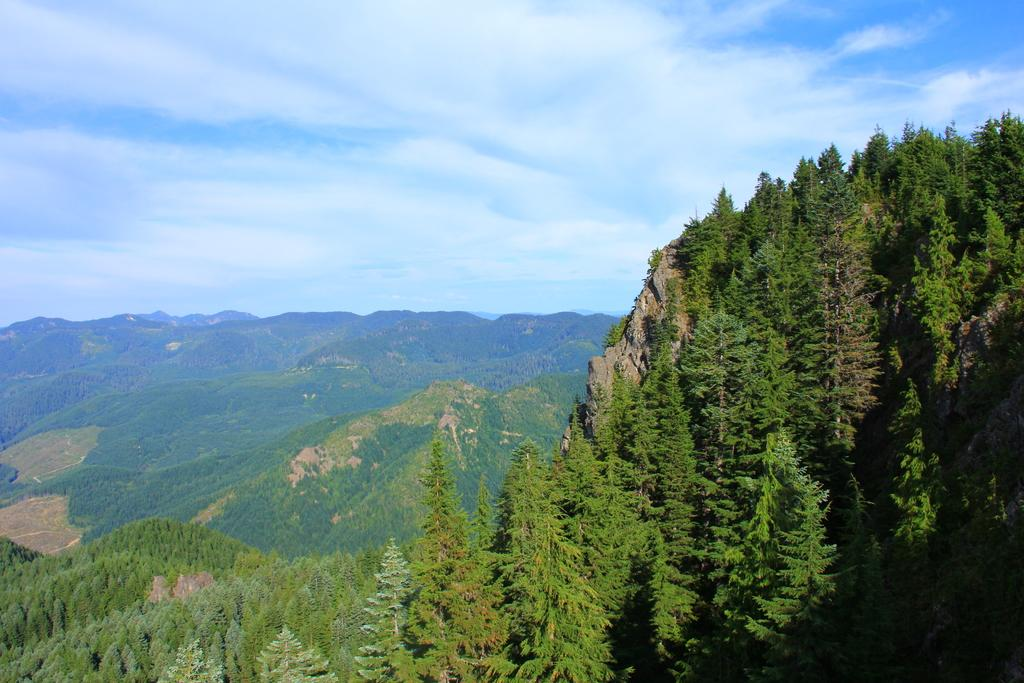What type of scene is shown in the image? The image depicts a scenery. What geographical features can be seen in the scenery? There are multiple hills in the scenery. What type of vegetation is present on the hills? Trees are present on the hills. What is visible at the top of the image? The sky is visible at the top of the image. What can be observed in the sky? Clouds are present in the sky. How many bushes are present on the hills in the image? There is no mention of bushes in the image; only trees are present on the hills. What direction is the scenery facing in the image? The image does not provide information about the direction the scenery is facing. 